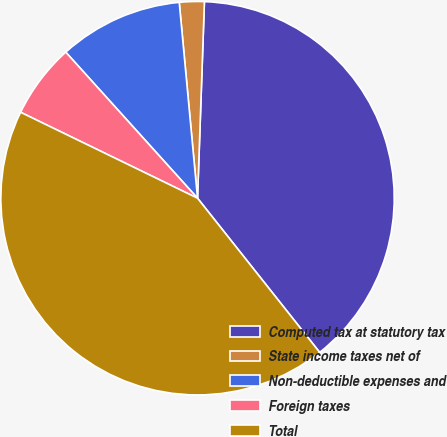Convert chart. <chart><loc_0><loc_0><loc_500><loc_500><pie_chart><fcel>Computed tax at statutory tax<fcel>State income taxes net of<fcel>Non-deductible expenses and<fcel>Foreign taxes<fcel>Total<nl><fcel>38.78%<fcel>2.04%<fcel>10.2%<fcel>6.12%<fcel>42.86%<nl></chart> 